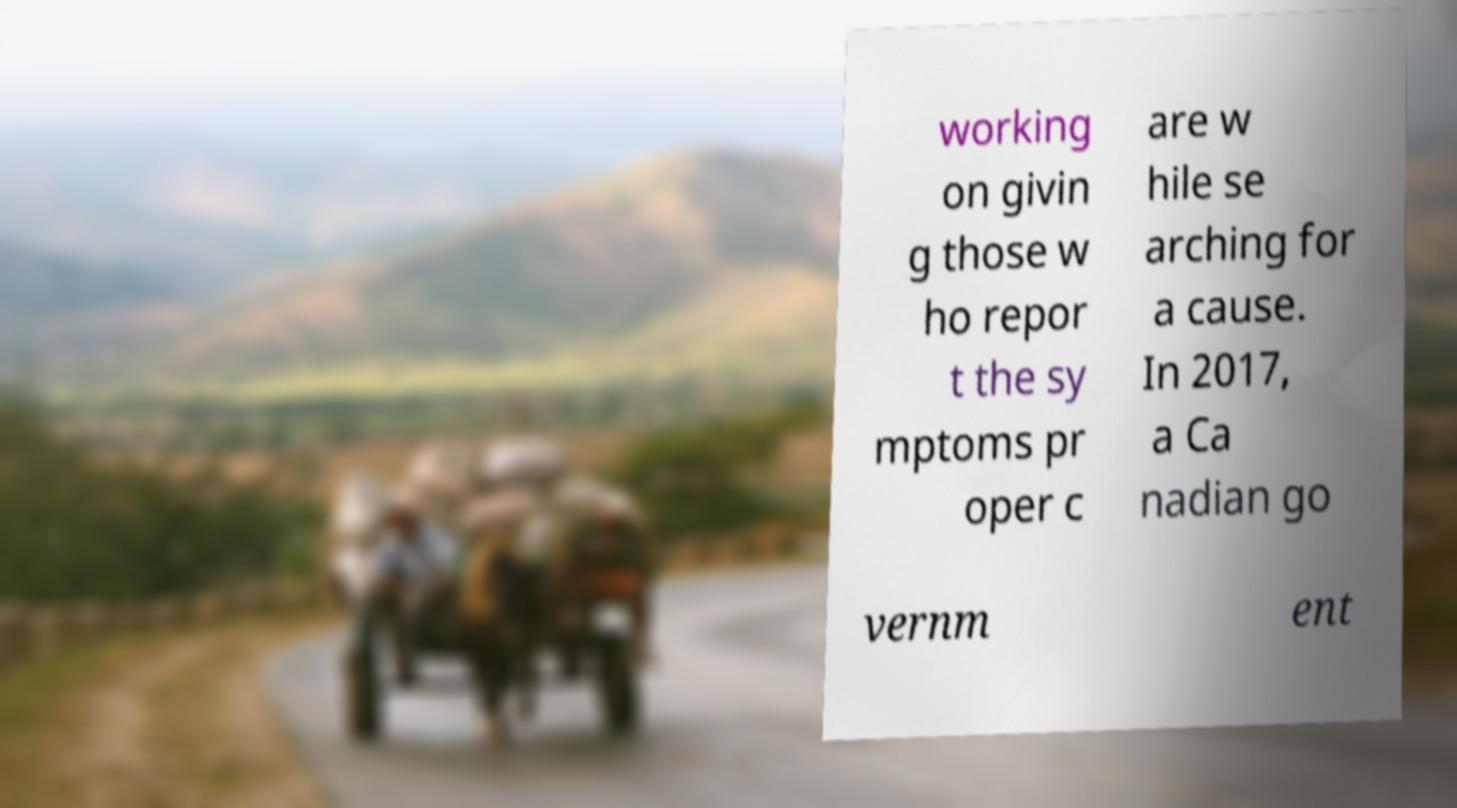Could you extract and type out the text from this image? working on givin g those w ho repor t the sy mptoms pr oper c are w hile se arching for a cause. In 2017, a Ca nadian go vernm ent 